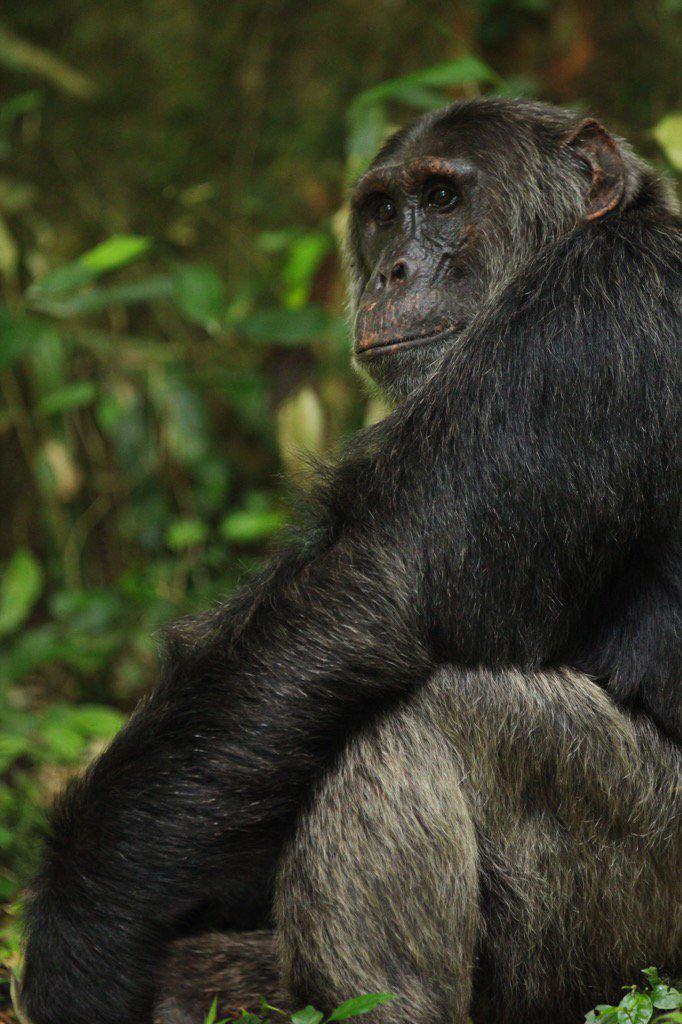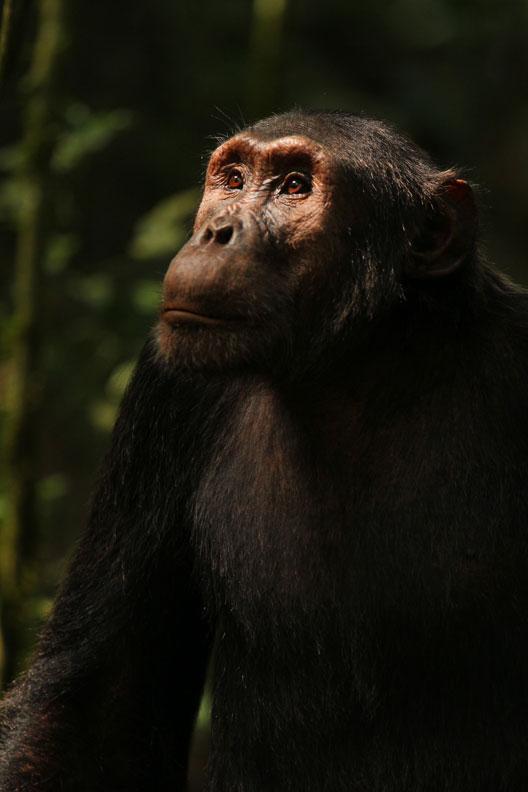The first image is the image on the left, the second image is the image on the right. Examine the images to the left and right. Is the description "Each image contains a single chimpanzee, and the chimps in the left and right images are gazing in the same general direction, but none look straight at the camera with a level gaze." accurate? Answer yes or no. Yes. 